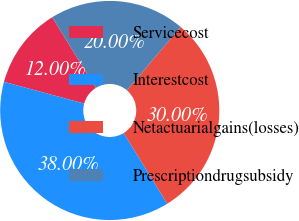Convert chart to OTSL. <chart><loc_0><loc_0><loc_500><loc_500><pie_chart><fcel>Servicecost<fcel>Interestcost<fcel>Netactuarialgains(losses)<fcel>Prescriptiondrugsubsidy<nl><fcel>12.0%<fcel>38.0%<fcel>30.0%<fcel>20.0%<nl></chart> 